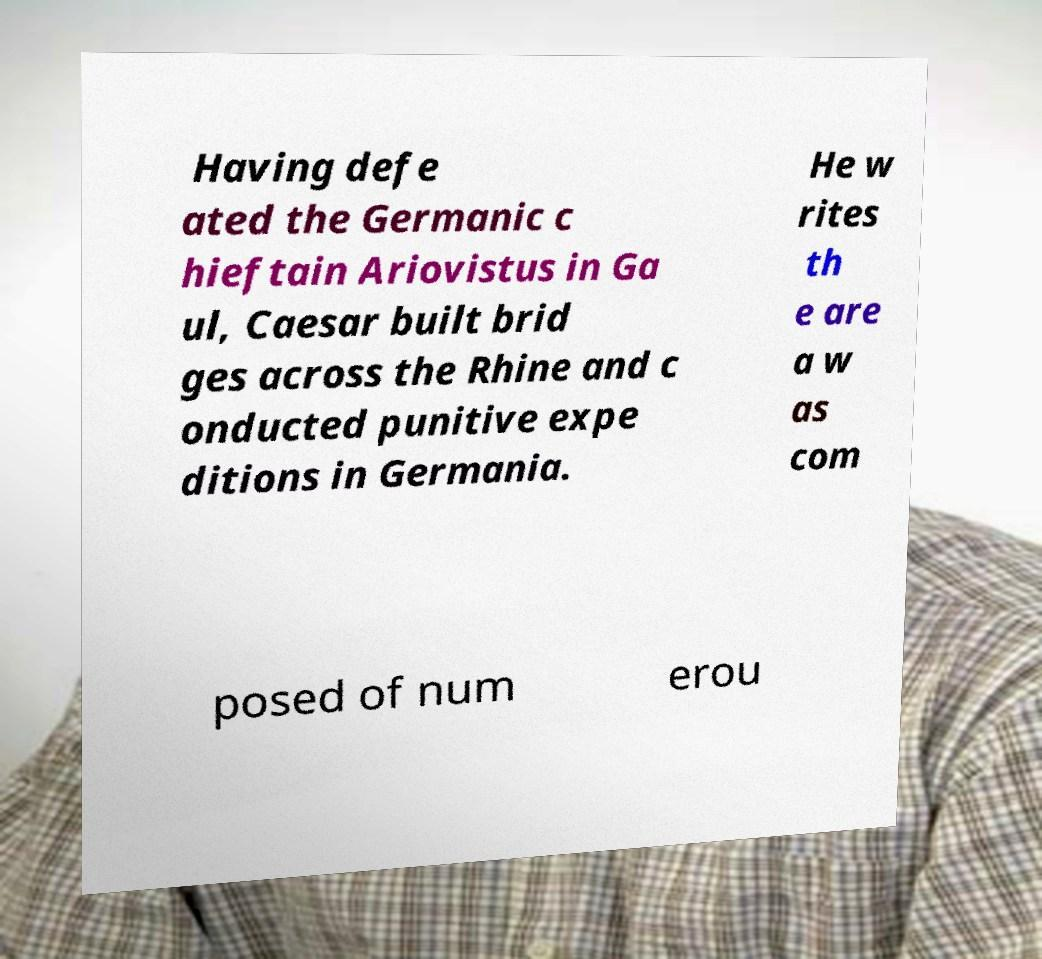Can you read and provide the text displayed in the image?This photo seems to have some interesting text. Can you extract and type it out for me? Having defe ated the Germanic c hieftain Ariovistus in Ga ul, Caesar built brid ges across the Rhine and c onducted punitive expe ditions in Germania. He w rites th e are a w as com posed of num erou 